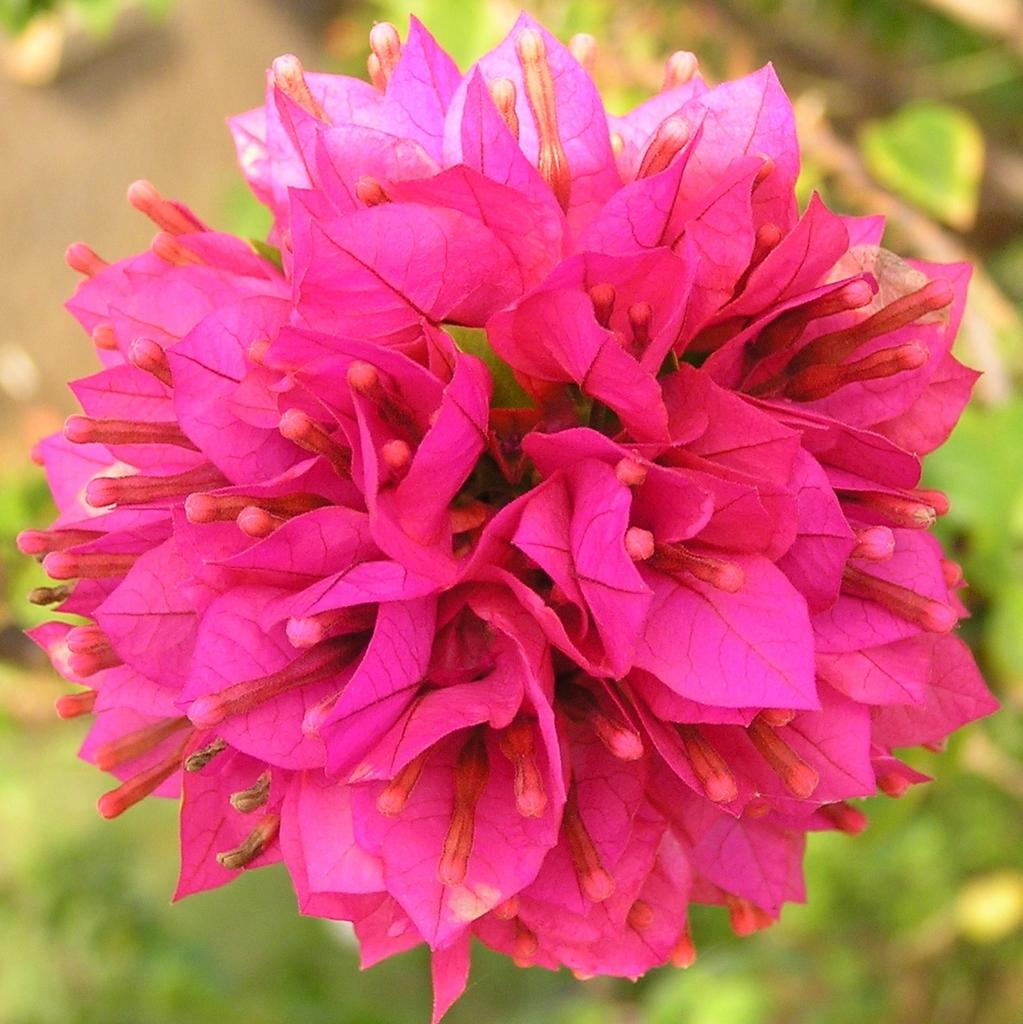What is the main subject in the front of the image? There is a flower in the front of the image. What can be seen in the background of the image? There are leaves in the background of the image. How would you describe the appearance of the background? The background appears blurry. Is there an apple in the image, and if so, where is it located? There is no apple present in the image. 